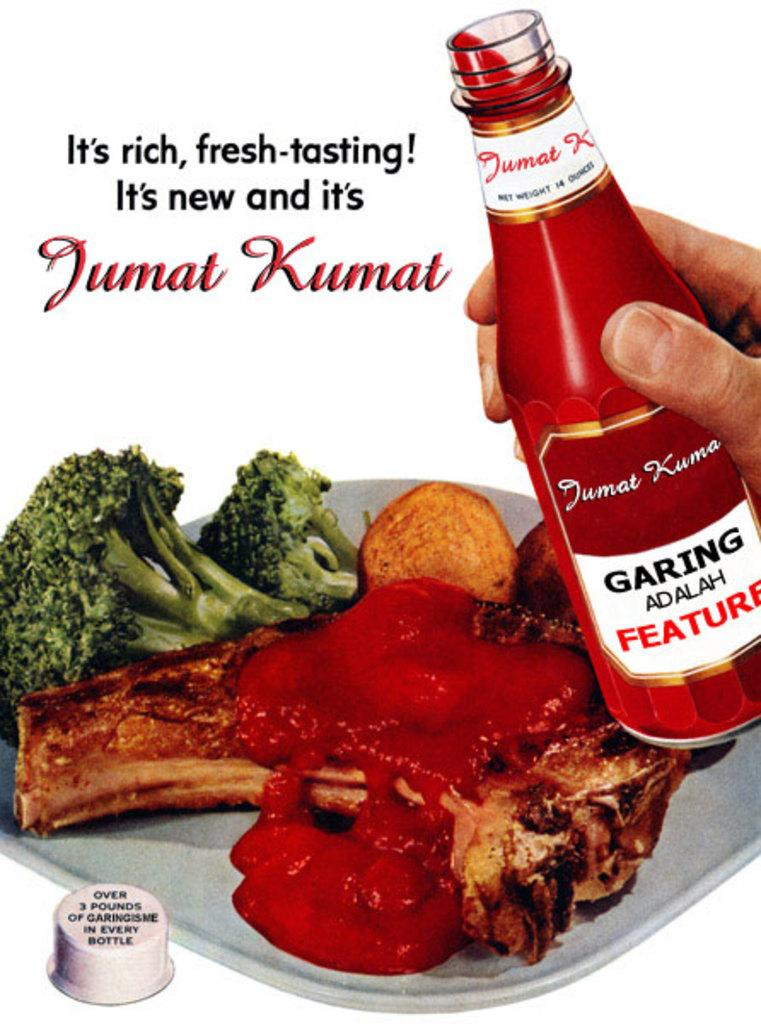<image>
Summarize the visual content of the image. A vintage looking ad for Jumat Kumat which appears to be a ketchup like condiment. 